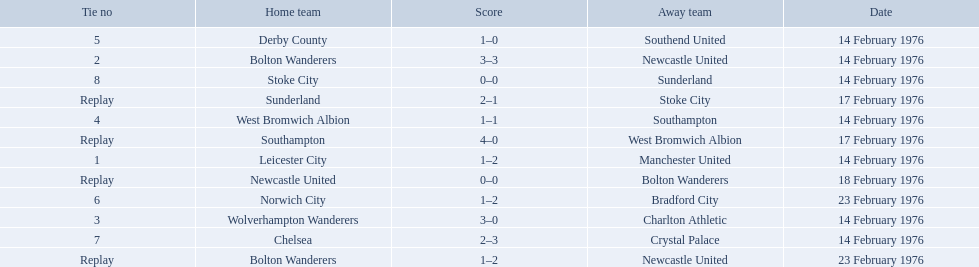Who were all the teams that played? Leicester City, Manchester United, Bolton Wanderers, Newcastle United, Newcastle United, Bolton Wanderers, Bolton Wanderers, Newcastle United, Wolverhampton Wanderers, Charlton Athletic, West Bromwich Albion, Southampton, Southampton, West Bromwich Albion, Derby County, Southend United, Norwich City, Bradford City, Chelsea, Crystal Palace, Stoke City, Sunderland, Sunderland, Stoke City. Which of these teams won? Manchester United, Newcastle United, Wolverhampton Wanderers, Southampton, Derby County, Bradford City, Crystal Palace, Sunderland. What was manchester united's winning score? 1–2. What was the wolverhampton wonders winning score? 3–0. Which of these two teams had the better winning score? Wolverhampton Wanderers. Who were all of the teams? Leicester City, Manchester United, Bolton Wanderers, Newcastle United, Newcastle United, Bolton Wanderers, Bolton Wanderers, Newcastle United, Wolverhampton Wanderers, Charlton Athletic, West Bromwich Albion, Southampton, Southampton, West Bromwich Albion, Derby County, Southend United, Norwich City, Bradford City, Chelsea, Crystal Palace, Stoke City, Sunderland, Sunderland, Stoke City. And what were their scores? 1–2, 3–3, 0–0, 1–2, 3–0, 1–1, 4–0, 1–0, 1–2, 2–3, 0–0, 2–1. Between manchester and wolverhampton, who scored more? Wolverhampton Wanderers. 